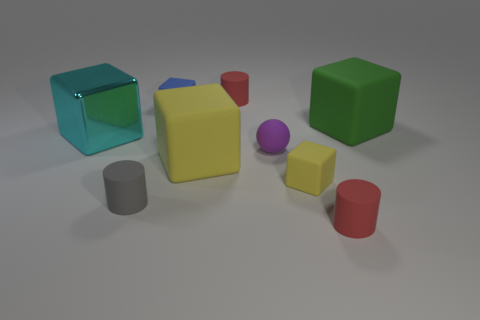Subtract 1 cubes. How many cubes are left? 4 Subtract all blue blocks. How many blocks are left? 4 Subtract all blue cubes. How many cubes are left? 4 Subtract all brown cubes. Subtract all cyan balls. How many cubes are left? 5 Subtract all balls. How many objects are left? 8 Subtract all tiny matte cylinders. Subtract all gray matte objects. How many objects are left? 5 Add 5 cyan cubes. How many cyan cubes are left? 6 Add 7 big cyan objects. How many big cyan objects exist? 8 Subtract 0 red balls. How many objects are left? 9 